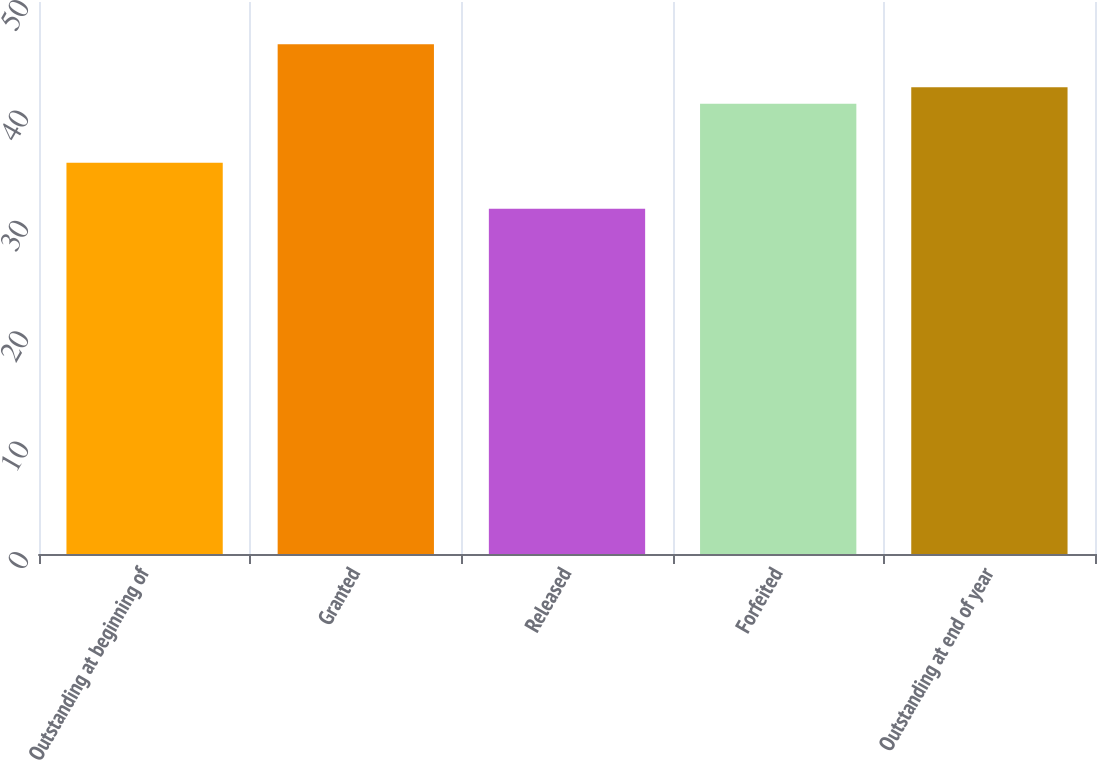Convert chart. <chart><loc_0><loc_0><loc_500><loc_500><bar_chart><fcel>Outstanding at beginning of<fcel>Granted<fcel>Released<fcel>Forfeited<fcel>Outstanding at end of year<nl><fcel>35.43<fcel>46.17<fcel>31.28<fcel>40.79<fcel>42.28<nl></chart> 